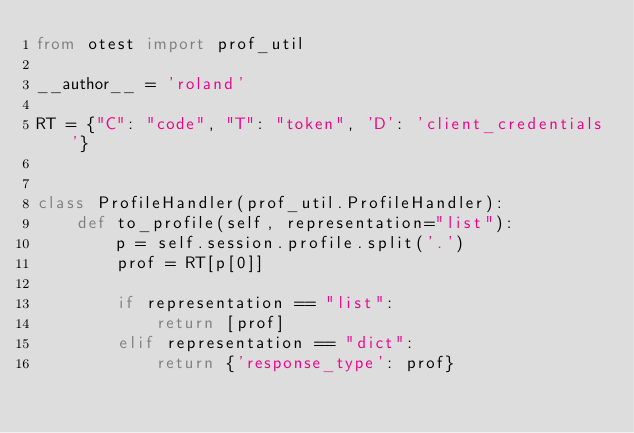Convert code to text. <code><loc_0><loc_0><loc_500><loc_500><_Python_>from otest import prof_util

__author__ = 'roland'

RT = {"C": "code", "T": "token", 'D': 'client_credentials'}


class ProfileHandler(prof_util.ProfileHandler):
    def to_profile(self, representation="list"):
        p = self.session.profile.split('.')
        prof = RT[p[0]]

        if representation == "list":
            return [prof]
        elif representation == "dict":
            return {'response_type': prof}
</code> 